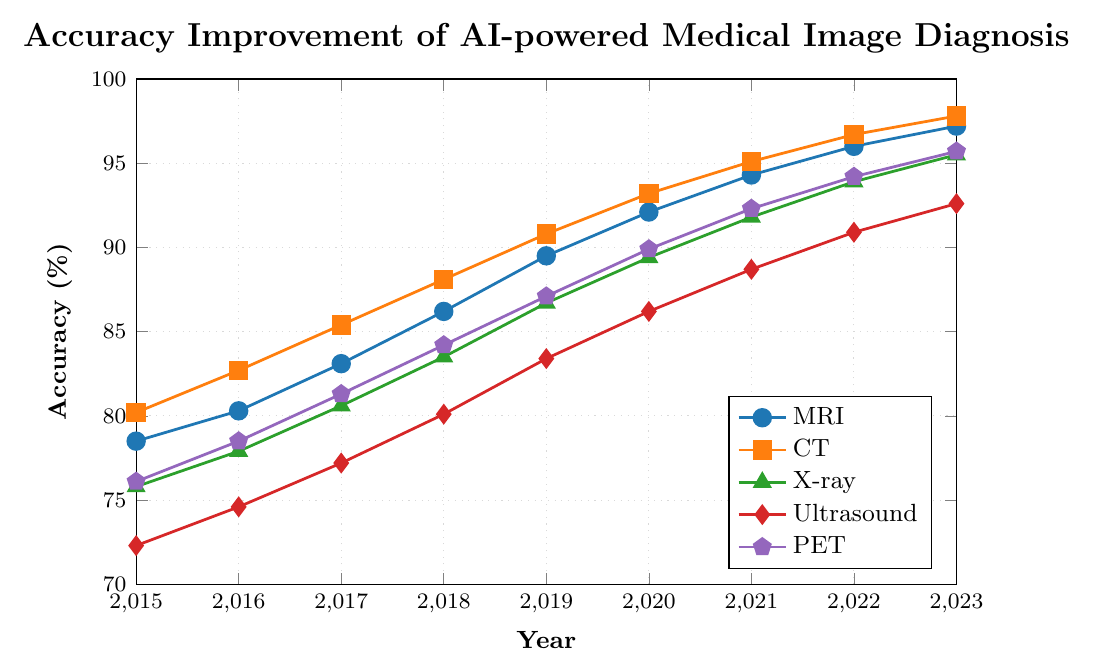What is the accuracy of MRI and CT in 2018 and by how much do they differ? The MRI accuracy in 2018 is 86.2% and the CT accuracy is 88.1%. The difference is calculated as 88.1 - 86.2 = 1.9%.
Answer: 1.9% Which imaging modality shows the highest accuracy in 2023? From the plot, in 2023, the CT imaging modality shows the highest accuracy at 97.8%.
Answer: CT By how many percentage points did the accuracy of Ultrasound improve from 2015 to 2023? The accuracy of Ultrasound in 2015 is 72.3%, and in 2023 it is 92.6%. The improvement is calculated as 92.6 - 72.3 = 20.3 percentage points.
Answer: 20.3 Which imaging modality had the lowest accuracy in 2016 and what was its value? In 2016, Ultrasound had the lowest accuracy at 74.6%.
Answer: Ultrasound at 74.6% Between 2017 and 2019, how many percentage points did the accuracy of X-ray improve? The accuracy of X-ray in 2017 is 80.6%, and in 2019 it is 86.7%. The improvement is calculated as 86.7 - 80.6 = 6.1 percentage points.
Answer: 6.1 What is the average accuracy of PET across the years 2015, 2016, and 2017? The accuracies for PET in 2015, 2016, and 2017 are 76.1%, 78.5%, and 81.3% respectively. The average is calculated as (76.1 + 78.5 + 81.3) / 3 = 78.63%.
Answer: 78.63 Which imaging modality had the steepest accuracy improvement between 2015 and 2023? By visually comparing the slopes of the lines on the graph, the MRI shows the steepest improvement in accuracy, starting from 78.5% in 2015 and reaching 97.2% in 2023, an increase of 18.7 percentage points.
Answer: MRI Are there any years where PET and X-ray accuracies were equal? By examining the data for each year, there are no instances where PET and X-ray accuracies were equal. The lines representing PET and X-ray never intersect.
Answer: No How many imaging modalities had accuracy greater than 90% in 2023? In 2023, MRI, CT, X-ray, and PET all have accuracies greater than 90% (97.2%, 97.8%, 95.5%, and 95.7% respectively). Ultrasound is also greater than 90% at 92.6%. Thus, all 5 modalities have accuracy greater than 90% in 2023.
Answer: 5 